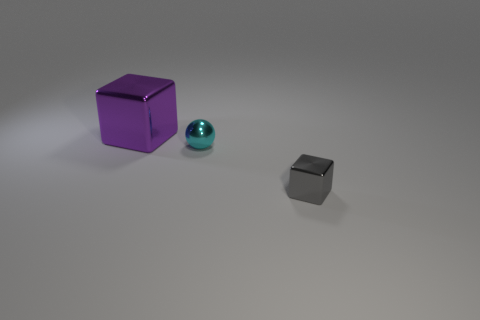Add 3 large purple metal blocks. How many objects exist? 6 Subtract all purple blocks. How many blocks are left? 1 Subtract all blocks. How many objects are left? 1 Subtract 2 cubes. How many cubes are left? 0 Subtract all brown spheres. Subtract all brown cubes. How many spheres are left? 1 Subtract all big balls. Subtract all big things. How many objects are left? 2 Add 3 small gray cubes. How many small gray cubes are left? 4 Add 3 cyan metal things. How many cyan metal things exist? 4 Subtract 0 brown cubes. How many objects are left? 3 